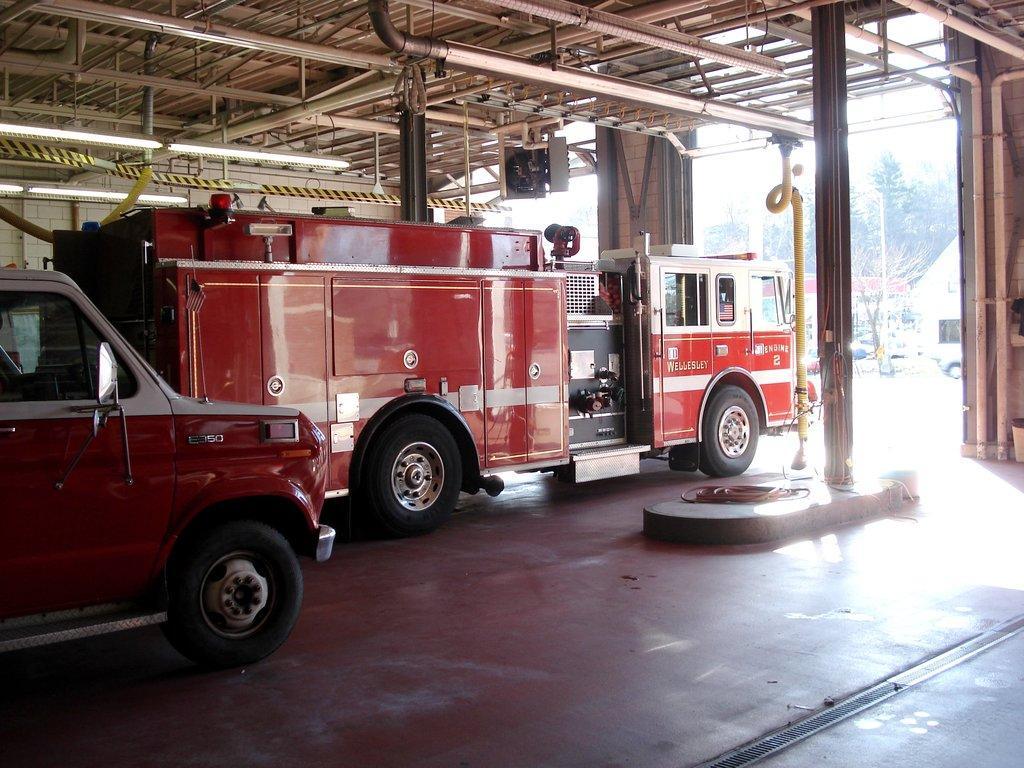Please provide a concise description of this image. This image is clicked inside a shed. There are vehicles parked inside the shed. There are metal rods and pipes to the ceiling. There are tube lights hanging to the ceiling. Outside the shed there are vehicles moving on the road. There are trees in the image. 